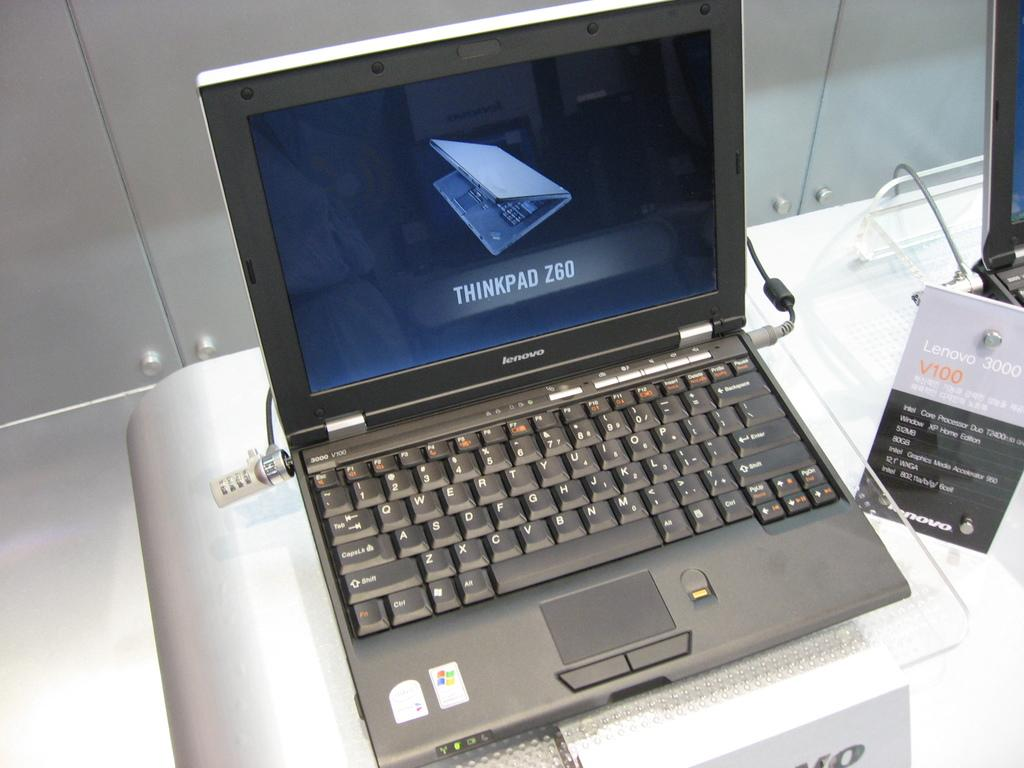What electronic device is visible in the image? There is a laptop in the image. Where is the laptop placed? The laptop is placed on a table. What can be seen in the background of the image? There is a wall in the background of the image. What type of current is flowing through the laptop in the image? There is no information about the laptop's power source or current in the image, so it cannot be determined. 